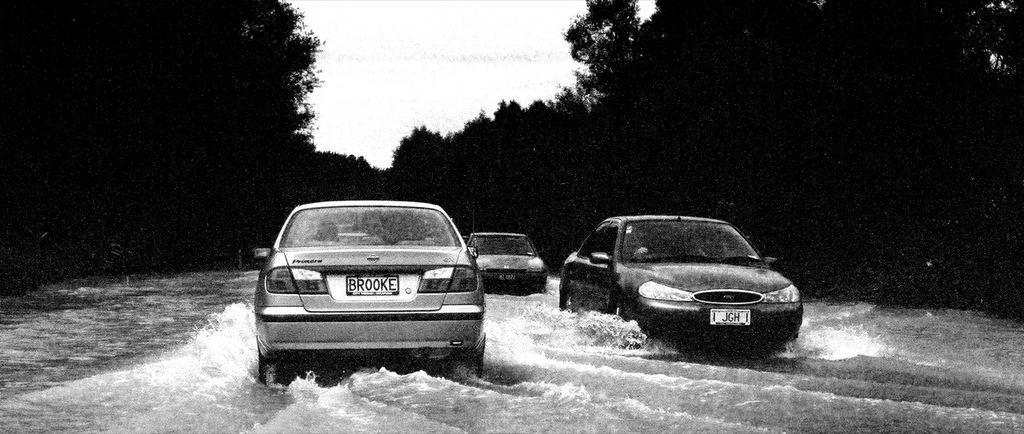How would you summarize this image in a sentence or two? In this image, I can see three cars. These are the water flowing. I can see the trees. This is the sky. 